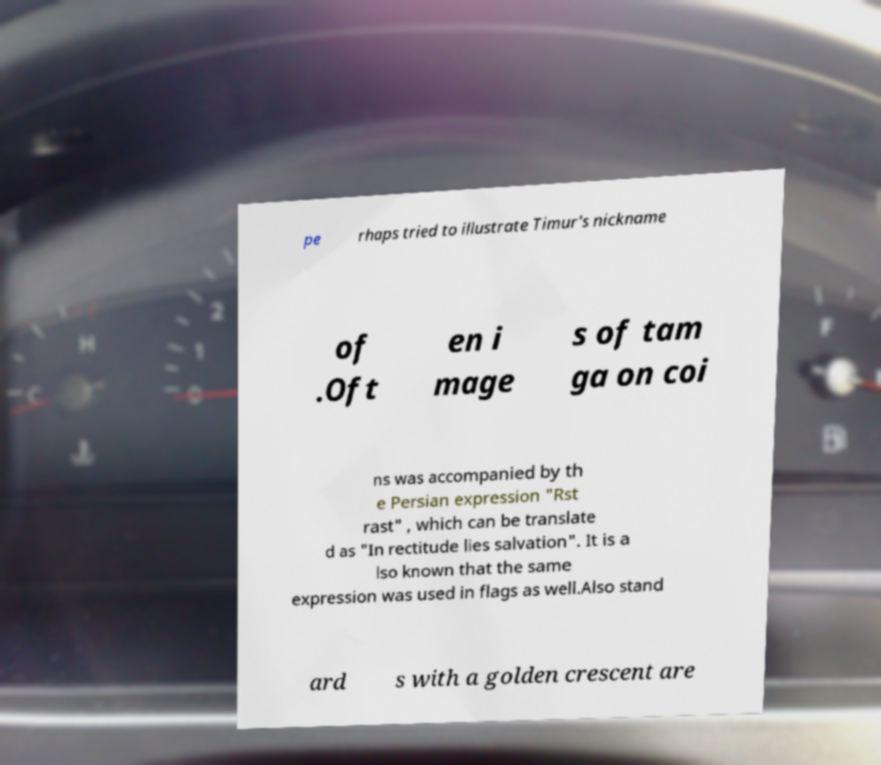Could you extract and type out the text from this image? pe rhaps tried to illustrate Timur's nickname of .Oft en i mage s of tam ga on coi ns was accompanied by th e Persian expression "Rst rast" , which can be translate d as "In rectitude lies salvation". It is a lso known that the same expression was used in flags as well.Also stand ard s with a golden crescent are 